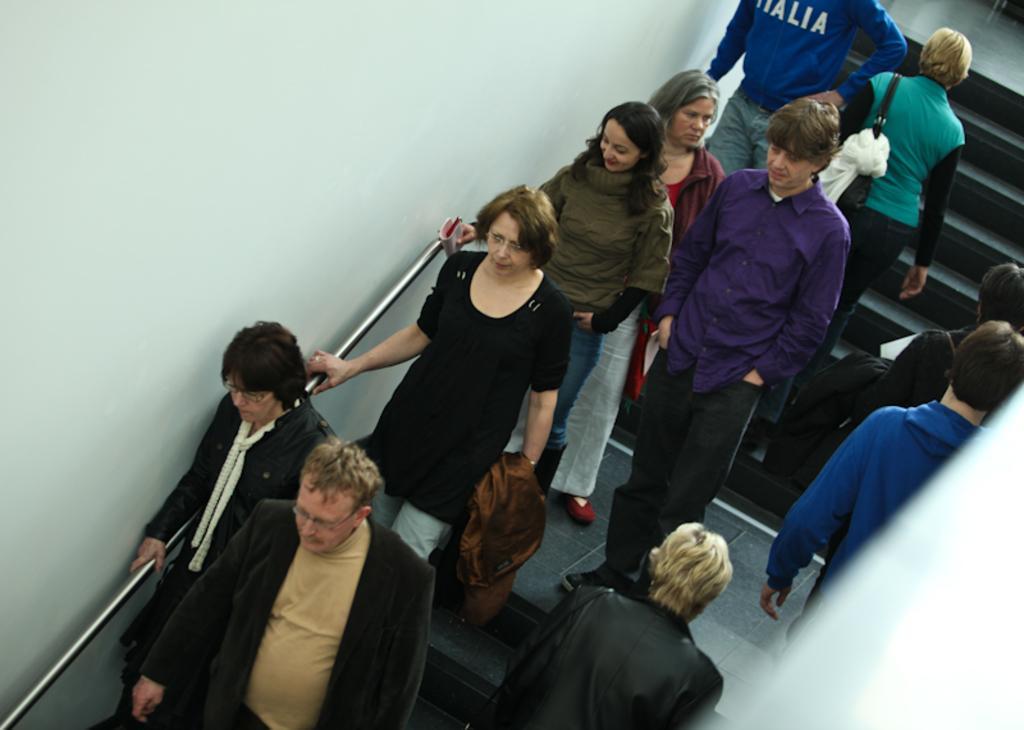How would you summarize this image in a sentence or two? In this image we can see a group of people standing on a staircase. One woman is holding a book in her hand. On the left side of the image we can see a metal pole. At the top of the image we can see the wall. 